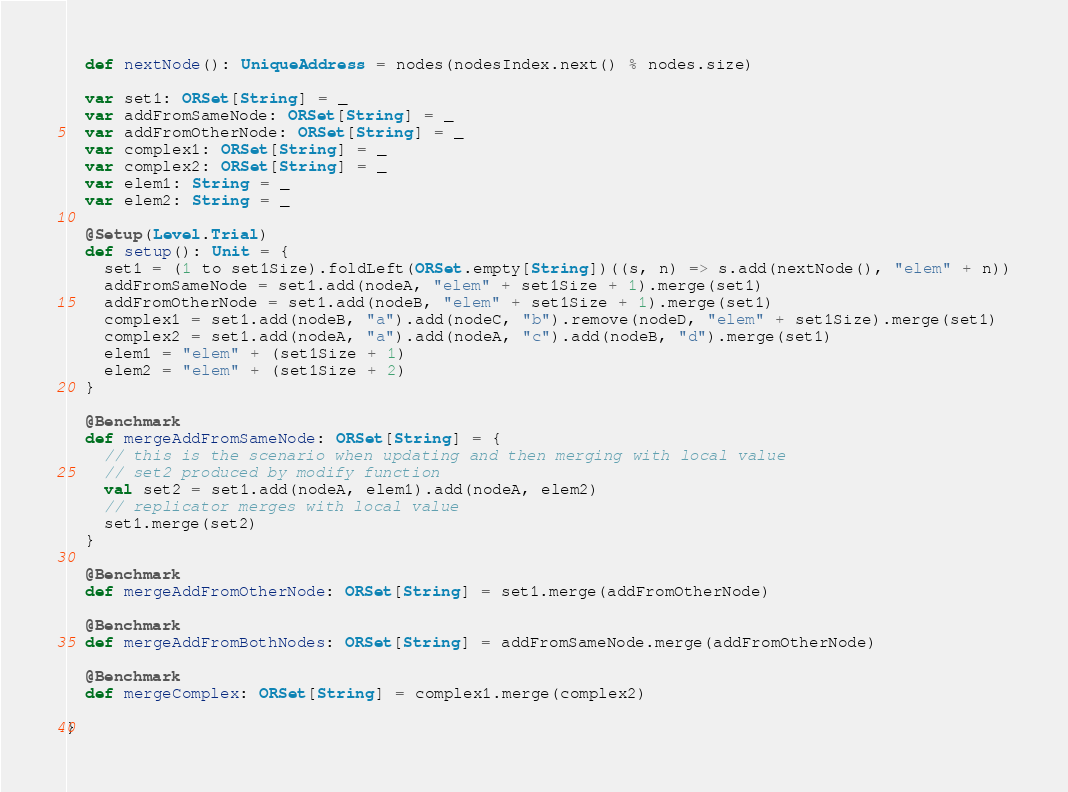Convert code to text. <code><loc_0><loc_0><loc_500><loc_500><_Scala_>  def nextNode(): UniqueAddress = nodes(nodesIndex.next() % nodes.size)

  var set1: ORSet[String] = _
  var addFromSameNode: ORSet[String] = _
  var addFromOtherNode: ORSet[String] = _
  var complex1: ORSet[String] = _
  var complex2: ORSet[String] = _
  var elem1: String = _
  var elem2: String = _

  @Setup(Level.Trial)
  def setup(): Unit = {
    set1 = (1 to set1Size).foldLeft(ORSet.empty[String])((s, n) => s.add(nextNode(), "elem" + n))
    addFromSameNode = set1.add(nodeA, "elem" + set1Size + 1).merge(set1)
    addFromOtherNode = set1.add(nodeB, "elem" + set1Size + 1).merge(set1)
    complex1 = set1.add(nodeB, "a").add(nodeC, "b").remove(nodeD, "elem" + set1Size).merge(set1)
    complex2 = set1.add(nodeA, "a").add(nodeA, "c").add(nodeB, "d").merge(set1)
    elem1 = "elem" + (set1Size + 1)
    elem2 = "elem" + (set1Size + 2)
  }

  @Benchmark
  def mergeAddFromSameNode: ORSet[String] = {
    // this is the scenario when updating and then merging with local value
    // set2 produced by modify function
    val set2 = set1.add(nodeA, elem1).add(nodeA, elem2)
    // replicator merges with local value
    set1.merge(set2)
  }

  @Benchmark
  def mergeAddFromOtherNode: ORSet[String] = set1.merge(addFromOtherNode)

  @Benchmark
  def mergeAddFromBothNodes: ORSet[String] = addFromSameNode.merge(addFromOtherNode)

  @Benchmark
  def mergeComplex: ORSet[String] = complex1.merge(complex2)

}
</code> 